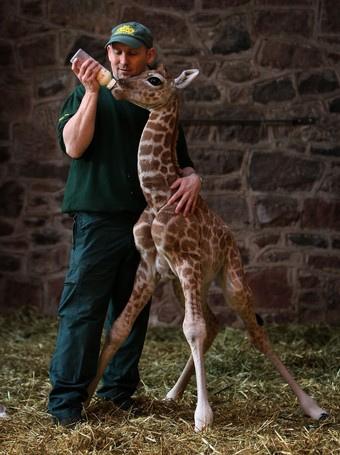What is the man doing?
Short answer required. Feeding giraffe. Is this a baby giraffe?
Give a very brief answer. Yes. Who is taller?
Write a very short answer. Man. What is the giraffe drinking out of?
Quick response, please. Bottle. 